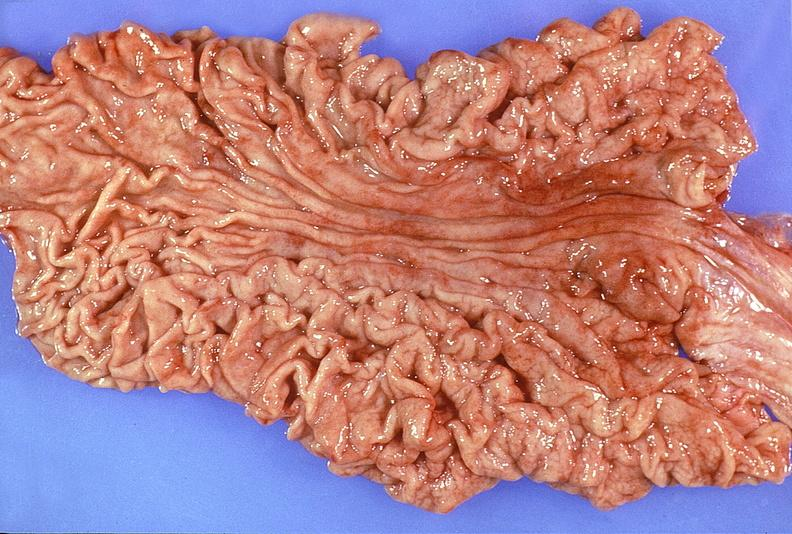where does this belong to?
Answer the question using a single word or phrase. Gastrointestinal system 